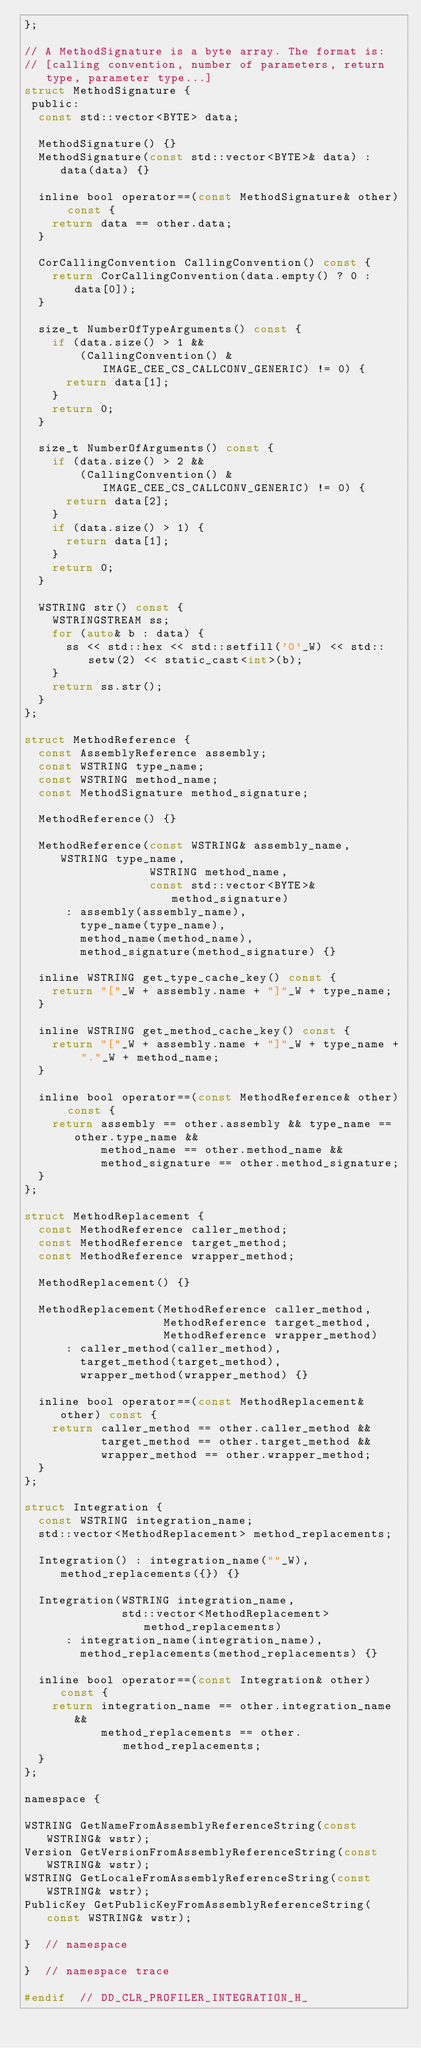Convert code to text. <code><loc_0><loc_0><loc_500><loc_500><_C_>};

// A MethodSignature is a byte array. The format is:
// [calling convention, number of parameters, return type, parameter type...]
struct MethodSignature {
 public:
  const std::vector<BYTE> data;

  MethodSignature() {}
  MethodSignature(const std::vector<BYTE>& data) : data(data) {}

  inline bool operator==(const MethodSignature& other) const {
    return data == other.data;
  }

  CorCallingConvention CallingConvention() const {
    return CorCallingConvention(data.empty() ? 0 : data[0]);
  }

  size_t NumberOfTypeArguments() const {
    if (data.size() > 1 &&
        (CallingConvention() & IMAGE_CEE_CS_CALLCONV_GENERIC) != 0) {
      return data[1];
    }
    return 0;
  }

  size_t NumberOfArguments() const {
    if (data.size() > 2 &&
        (CallingConvention() & IMAGE_CEE_CS_CALLCONV_GENERIC) != 0) {
      return data[2];
    }
    if (data.size() > 1) {
      return data[1];
    }
    return 0;
  }

  WSTRING str() const {
    WSTRINGSTREAM ss;
    for (auto& b : data) {
      ss << std::hex << std::setfill('0'_W) << std::setw(2) << static_cast<int>(b);
    }
    return ss.str();
  }
};

struct MethodReference {
  const AssemblyReference assembly;
  const WSTRING type_name;
  const WSTRING method_name;
  const MethodSignature method_signature;

  MethodReference() {}

  MethodReference(const WSTRING& assembly_name, WSTRING type_name,
                  WSTRING method_name,
                  const std::vector<BYTE>& method_signature)
      : assembly(assembly_name),
        type_name(type_name),
        method_name(method_name),
        method_signature(method_signature) {}

  inline WSTRING get_type_cache_key() const {
    return "["_W + assembly.name + "]"_W + type_name;
  }

  inline WSTRING get_method_cache_key() const {
    return "["_W + assembly.name + "]"_W + type_name + "."_W + method_name;
  }

  inline bool operator==(const MethodReference& other) const {
    return assembly == other.assembly && type_name == other.type_name &&
           method_name == other.method_name &&
           method_signature == other.method_signature;
  }
};

struct MethodReplacement {
  const MethodReference caller_method;
  const MethodReference target_method;
  const MethodReference wrapper_method;

  MethodReplacement() {}

  MethodReplacement(MethodReference caller_method,
                    MethodReference target_method,
                    MethodReference wrapper_method)
      : caller_method(caller_method),
        target_method(target_method),
        wrapper_method(wrapper_method) {}

  inline bool operator==(const MethodReplacement& other) const {
    return caller_method == other.caller_method &&
           target_method == other.target_method &&
           wrapper_method == other.wrapper_method;
  }
};

struct Integration {
  const WSTRING integration_name;
  std::vector<MethodReplacement> method_replacements;

  Integration() : integration_name(""_W), method_replacements({}) {}

  Integration(WSTRING integration_name,
              std::vector<MethodReplacement> method_replacements)
      : integration_name(integration_name),
        method_replacements(method_replacements) {}

  inline bool operator==(const Integration& other) const {
    return integration_name == other.integration_name &&
           method_replacements == other.method_replacements;
  }
};

namespace {

WSTRING GetNameFromAssemblyReferenceString(const WSTRING& wstr);
Version GetVersionFromAssemblyReferenceString(const WSTRING& wstr);
WSTRING GetLocaleFromAssemblyReferenceString(const WSTRING& wstr);
PublicKey GetPublicKeyFromAssemblyReferenceString(const WSTRING& wstr);

}  // namespace

}  // namespace trace

#endif  // DD_CLR_PROFILER_INTEGRATION_H_
</code> 